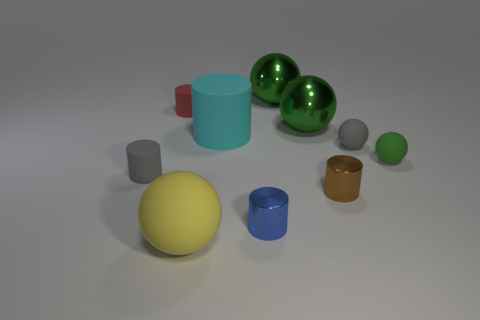Subtract all green balls. How many were subtracted if there are1green balls left? 2 Subtract all green cubes. How many green spheres are left? 3 Subtract all brown cylinders. How many cylinders are left? 4 Subtract all blue spheres. Subtract all brown cylinders. How many spheres are left? 5 Subtract 0 green cylinders. How many objects are left? 10 Subtract all small red rubber cylinders. Subtract all big brown metal things. How many objects are left? 9 Add 6 big cylinders. How many big cylinders are left? 7 Add 4 small brown cylinders. How many small brown cylinders exist? 5 